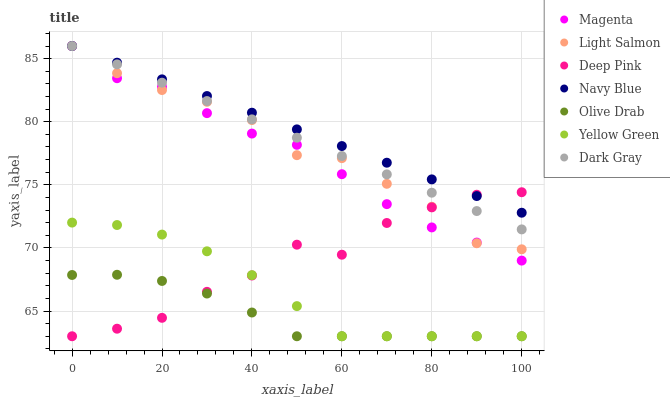Does Olive Drab have the minimum area under the curve?
Answer yes or no. Yes. Does Navy Blue have the maximum area under the curve?
Answer yes or no. Yes. Does Deep Pink have the minimum area under the curve?
Answer yes or no. No. Does Deep Pink have the maximum area under the curve?
Answer yes or no. No. Is Navy Blue the smoothest?
Answer yes or no. Yes. Is Deep Pink the roughest?
Answer yes or no. Yes. Is Yellow Green the smoothest?
Answer yes or no. No. Is Yellow Green the roughest?
Answer yes or no. No. Does Deep Pink have the lowest value?
Answer yes or no. Yes. Does Navy Blue have the lowest value?
Answer yes or no. No. Does Magenta have the highest value?
Answer yes or no. Yes. Does Deep Pink have the highest value?
Answer yes or no. No. Is Yellow Green less than Dark Gray?
Answer yes or no. Yes. Is Light Salmon greater than Olive Drab?
Answer yes or no. Yes. Does Magenta intersect Light Salmon?
Answer yes or no. Yes. Is Magenta less than Light Salmon?
Answer yes or no. No. Is Magenta greater than Light Salmon?
Answer yes or no. No. Does Yellow Green intersect Dark Gray?
Answer yes or no. No. 